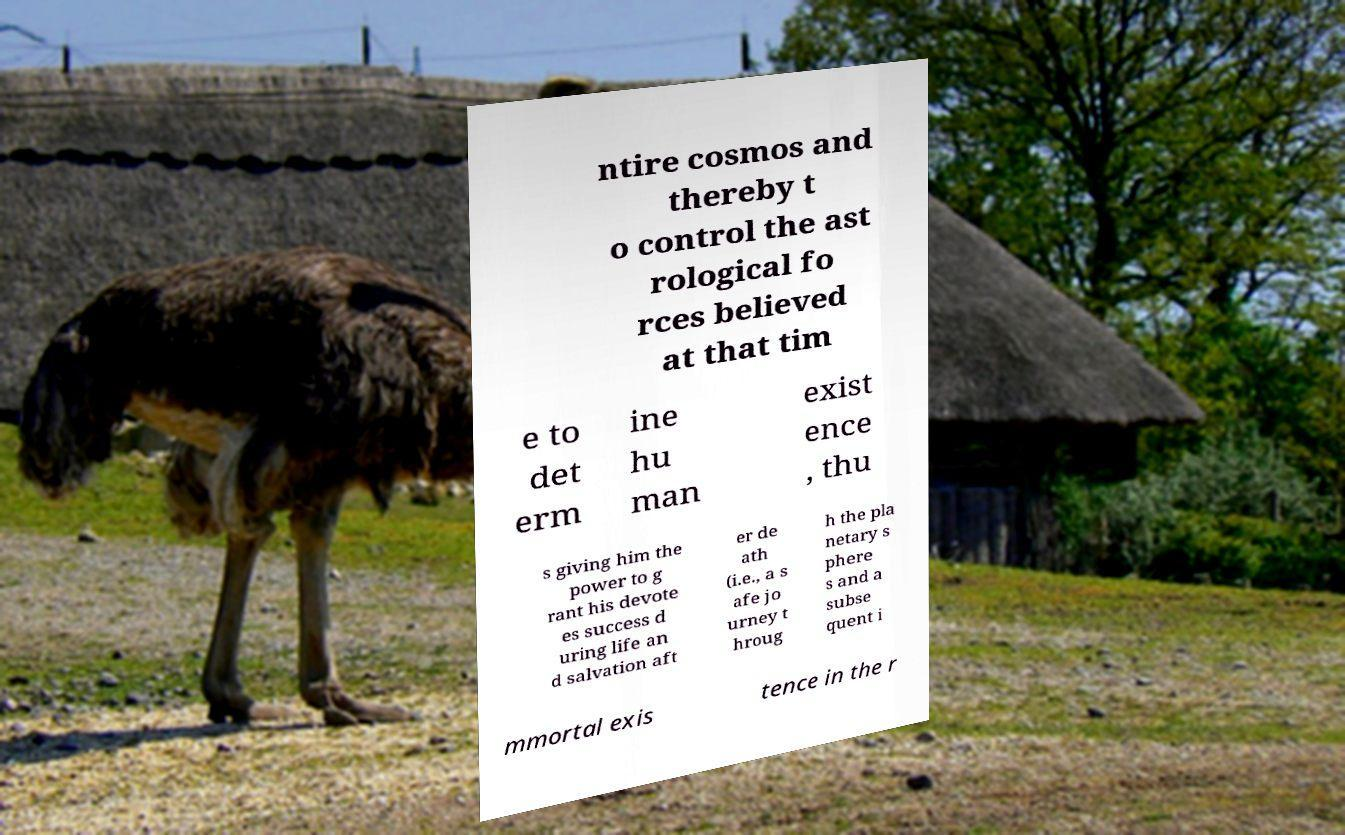Could you assist in decoding the text presented in this image and type it out clearly? ntire cosmos and thereby t o control the ast rological fo rces believed at that tim e to det erm ine hu man exist ence , thu s giving him the power to g rant his devote es success d uring life an d salvation aft er de ath (i.e., a s afe jo urney t hroug h the pla netary s phere s and a subse quent i mmortal exis tence in the r 